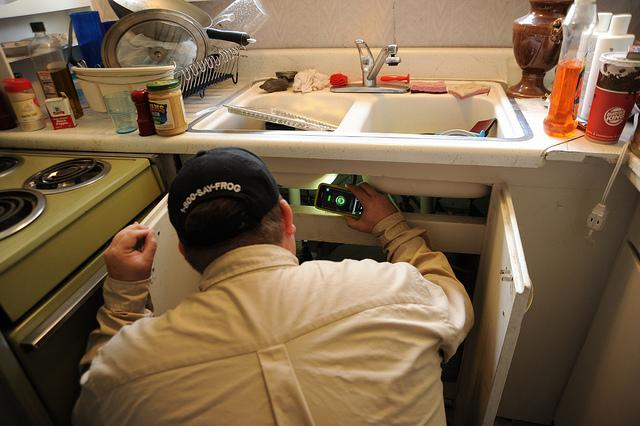What is the man using the phone as? Please explain your reasoning. flash light. The man is using the phone as a flash light to see. 